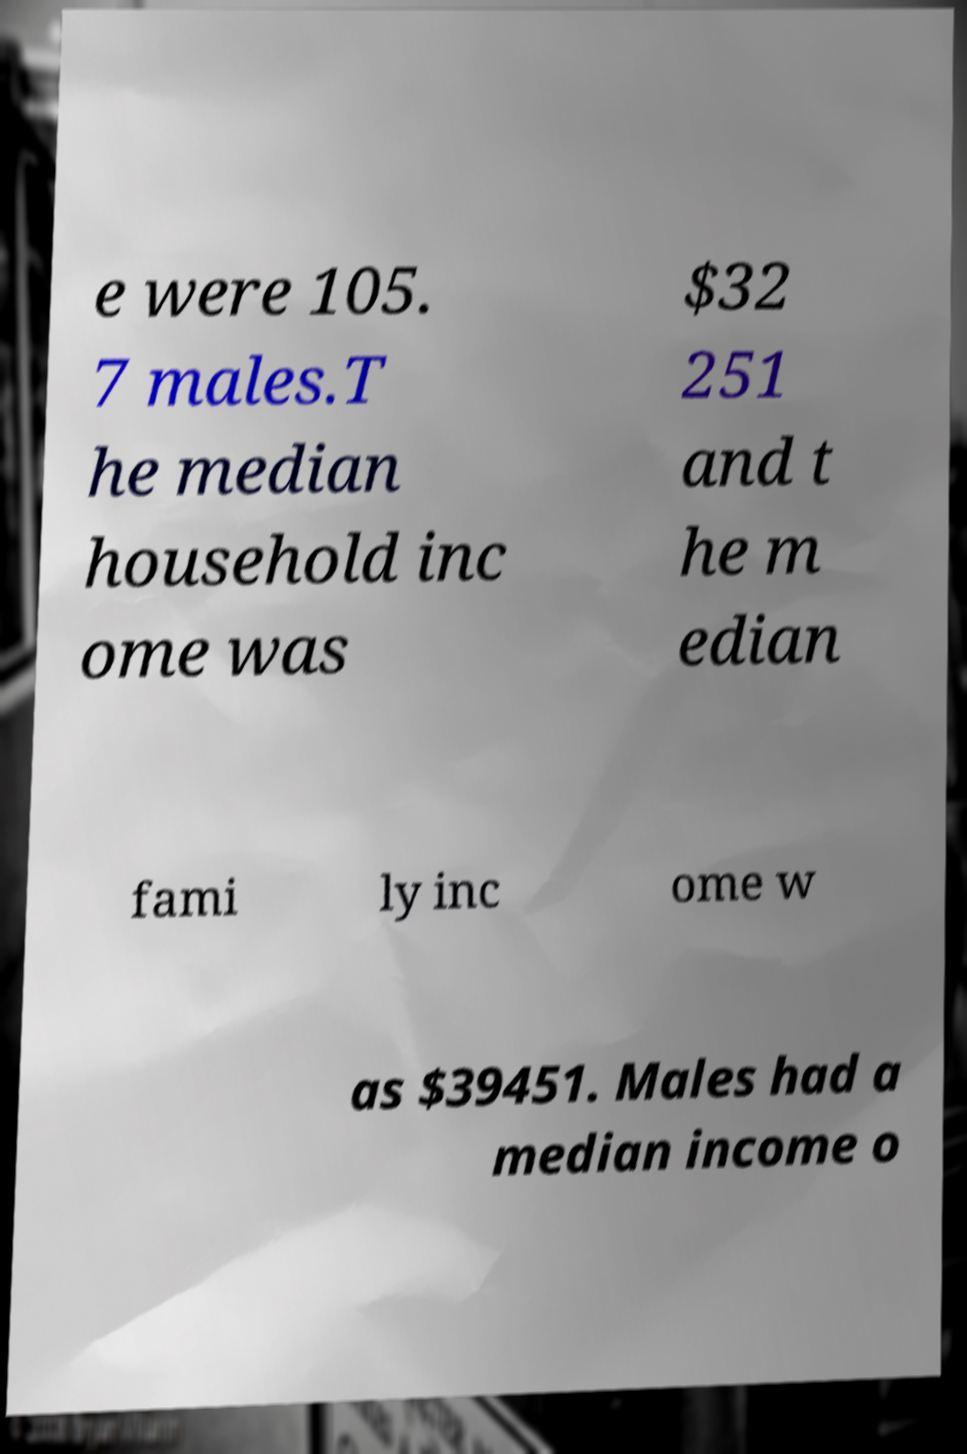For documentation purposes, I need the text within this image transcribed. Could you provide that? e were 105. 7 males.T he median household inc ome was $32 251 and t he m edian fami ly inc ome w as $39451. Males had a median income o 